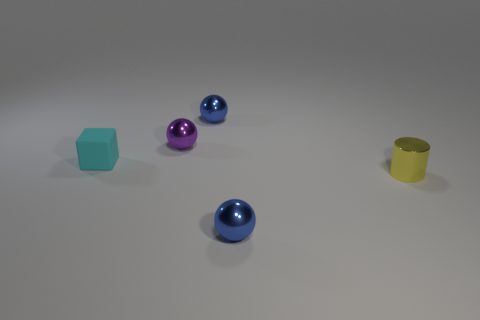Are there any small cyan objects on the right side of the small blue thing in front of the yellow metal thing that is in front of the purple ball?
Your answer should be compact. No. Is there anything else that has the same material as the cylinder?
Offer a terse response. Yes. There is a tiny purple object that is the same material as the yellow cylinder; what shape is it?
Keep it short and to the point. Sphere. Is the number of tiny objects that are left of the rubber block less than the number of blue objects left of the shiny cylinder?
Provide a short and direct response. Yes. What number of small things are blue balls or purple things?
Keep it short and to the point. 3. There is a tiny blue metal thing in front of the cyan thing; is it the same shape as the object behind the small purple shiny ball?
Offer a terse response. Yes. There is a sphere in front of the metal thing on the right side of the small sphere that is in front of the small matte object; what is its size?
Your answer should be compact. Small. How big is the cube that is left of the yellow thing?
Offer a terse response. Small. What material is the small sphere behind the purple metallic object?
Your response must be concise. Metal. How many green objects are either cylinders or shiny things?
Offer a very short reply. 0. 